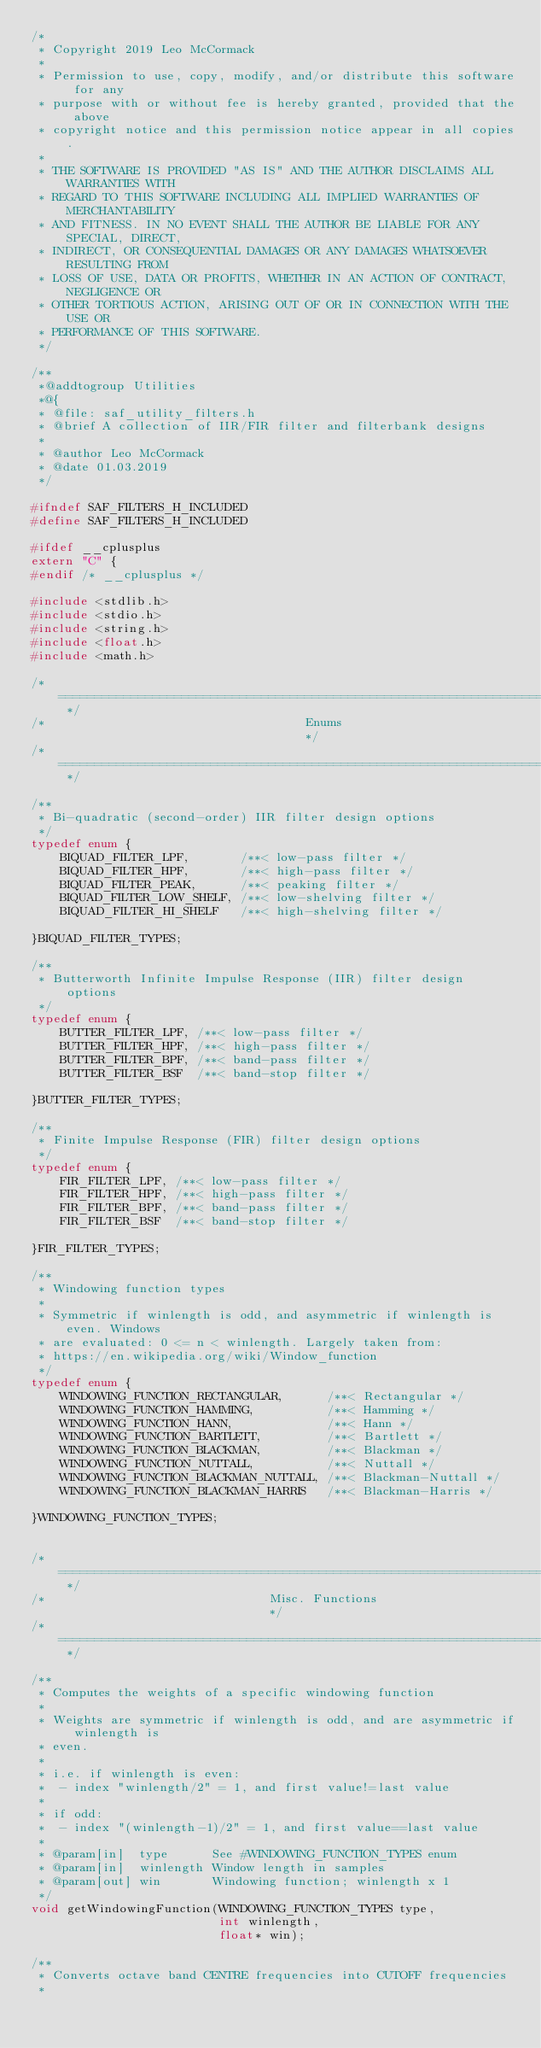Convert code to text. <code><loc_0><loc_0><loc_500><loc_500><_C_>/*
 * Copyright 2019 Leo McCormack
 *
 * Permission to use, copy, modify, and/or distribute this software for any
 * purpose with or without fee is hereby granted, provided that the above
 * copyright notice and this permission notice appear in all copies.
 *
 * THE SOFTWARE IS PROVIDED "AS IS" AND THE AUTHOR DISCLAIMS ALL WARRANTIES WITH
 * REGARD TO THIS SOFTWARE INCLUDING ALL IMPLIED WARRANTIES OF MERCHANTABILITY
 * AND FITNESS. IN NO EVENT SHALL THE AUTHOR BE LIABLE FOR ANY SPECIAL, DIRECT,
 * INDIRECT, OR CONSEQUENTIAL DAMAGES OR ANY DAMAGES WHATSOEVER RESULTING FROM
 * LOSS OF USE, DATA OR PROFITS, WHETHER IN AN ACTION OF CONTRACT, NEGLIGENCE OR
 * OTHER TORTIOUS ACTION, ARISING OUT OF OR IN CONNECTION WITH THE USE OR
 * PERFORMANCE OF THIS SOFTWARE.
 */

/**
 *@addtogroup Utilities
 *@{
 * @file: saf_utility_filters.h
 * @brief A collection of IIR/FIR filter and filterbank designs
 *
 * @author Leo McCormack
 * @date 01.03.2019 
 */

#ifndef SAF_FILTERS_H_INCLUDED
#define SAF_FILTERS_H_INCLUDED

#ifdef __cplusplus
extern "C" {
#endif /* __cplusplus */
    
#include <stdlib.h>
#include <stdio.h>
#include <string.h>
#include <float.h>
#include <math.h>

/* ========================================================================== */
/*                                    Enums                                   */
/* ========================================================================== */

/**
 * Bi-quadratic (second-order) IIR filter design options
 */
typedef enum {
    BIQUAD_FILTER_LPF,       /**< low-pass filter */
    BIQUAD_FILTER_HPF,       /**< high-pass filter */
    BIQUAD_FILTER_PEAK,      /**< peaking filter */
    BIQUAD_FILTER_LOW_SHELF, /**< low-shelving filter */
    BIQUAD_FILTER_HI_SHELF   /**< high-shelving filter */
    
}BIQUAD_FILTER_TYPES;

/**
 * Butterworth Infinite Impulse Response (IIR) filter design options
 */
typedef enum {
    BUTTER_FILTER_LPF, /**< low-pass filter */
    BUTTER_FILTER_HPF, /**< high-pass filter */
    BUTTER_FILTER_BPF, /**< band-pass filter */
    BUTTER_FILTER_BSF  /**< band-stop filter */

}BUTTER_FILTER_TYPES;

/**
 * Finite Impulse Response (FIR) filter design options
 */
typedef enum {
    FIR_FILTER_LPF, /**< low-pass filter */
    FIR_FILTER_HPF, /**< high-pass filter */
    FIR_FILTER_BPF, /**< band-pass filter */
    FIR_FILTER_BSF  /**< band-stop filter */
    
}FIR_FILTER_TYPES;

/**
 * Windowing function types
 *
 * Symmetric if winlength is odd, and asymmetric if winlength is even. Windows
 * are evaluated: 0 <= n < winlength. Largely taken from:
 * https://en.wikipedia.org/wiki/Window_function
 */
typedef enum {
    WINDOWING_FUNCTION_RECTANGULAR,      /**< Rectangular */
    WINDOWING_FUNCTION_HAMMING,          /**< Hamming */
    WINDOWING_FUNCTION_HANN,             /**< Hann */
    WINDOWING_FUNCTION_BARTLETT,         /**< Bartlett */
    WINDOWING_FUNCTION_BLACKMAN,         /**< Blackman */
    WINDOWING_FUNCTION_NUTTALL,          /**< Nuttall */
    WINDOWING_FUNCTION_BLACKMAN_NUTTALL, /**< Blackman-Nuttall */
    WINDOWING_FUNCTION_BLACKMAN_HARRIS   /**< Blackman-Harris */
    
}WINDOWING_FUNCTION_TYPES;


/* ========================================================================== */
/*                               Misc. Functions                              */
/* ========================================================================== */

/**
 * Computes the weights of a specific windowing function
 *
 * Weights are symmetric if winlength is odd, and are asymmetric if winlength is
 * even.
 *
 * i.e. if winlength is even:
 *  - index "winlength/2" = 1, and first value!=last value
 *
 * if odd:
 *  - index "(winlength-1)/2" = 1, and first value==last value
 *
 * @param[in]  type      See #WINDOWING_FUNCTION_TYPES enum
 * @param[in]  winlength Window length in samples
 * @param[out] win       Windowing function; winlength x 1
 */
void getWindowingFunction(WINDOWING_FUNCTION_TYPES type,
                          int winlength,
                          float* win);

/**
 * Converts octave band CENTRE frequencies into CUTOFF frequencies
 *</code> 